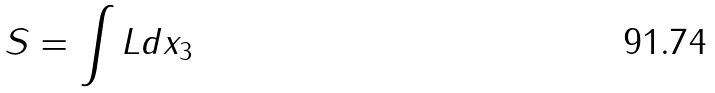Convert formula to latex. <formula><loc_0><loc_0><loc_500><loc_500>S = \int L d x _ { 3 }</formula> 